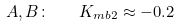<formula> <loc_0><loc_0><loc_500><loc_500>A , B \colon \quad K _ { m b 2 } \approx - 0 . 2</formula> 